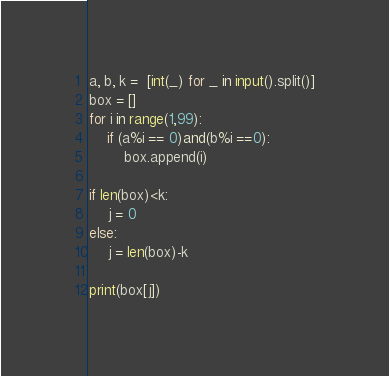<code> <loc_0><loc_0><loc_500><loc_500><_Python_>a, b, k =  [int(_) for _ in input().split()]
box = []
for i in range(1,99):
    if (a%i == 0)and(b%i ==0):
        box.append(i)

if len(box)<k:
    j = 0
else:
    j = len(box)-k

print(box[j])</code> 